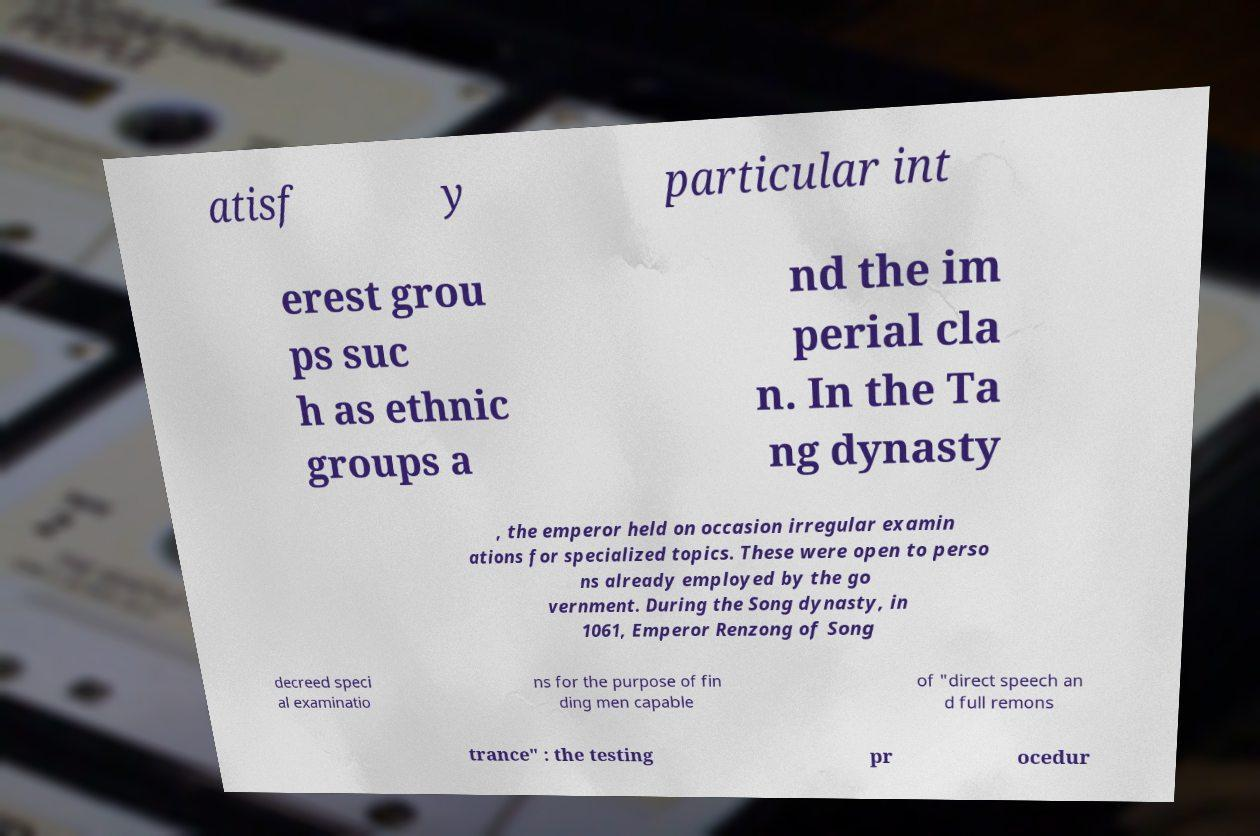Could you assist in decoding the text presented in this image and type it out clearly? atisf y particular int erest grou ps suc h as ethnic groups a nd the im perial cla n. In the Ta ng dynasty , the emperor held on occasion irregular examin ations for specialized topics. These were open to perso ns already employed by the go vernment. During the Song dynasty, in 1061, Emperor Renzong of Song decreed speci al examinatio ns for the purpose of fin ding men capable of "direct speech an d full remons trance" : the testing pr ocedur 